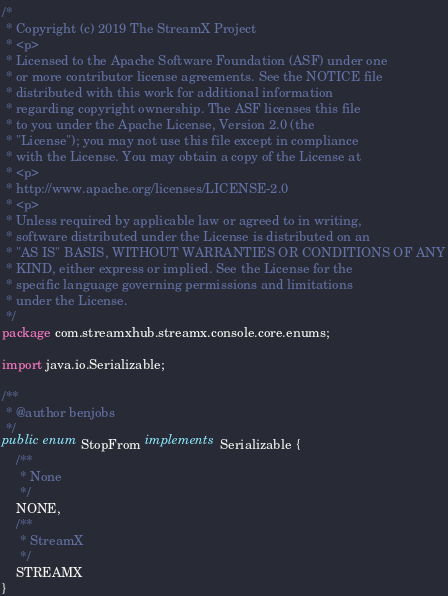Convert code to text. <code><loc_0><loc_0><loc_500><loc_500><_Java_>/*
 * Copyright (c) 2019 The StreamX Project
 * <p>
 * Licensed to the Apache Software Foundation (ASF) under one
 * or more contributor license agreements. See the NOTICE file
 * distributed with this work for additional information
 * regarding copyright ownership. The ASF licenses this file
 * to you under the Apache License, Version 2.0 (the
 * "License"); you may not use this file except in compliance
 * with the License. You may obtain a copy of the License at
 * <p>
 * http://www.apache.org/licenses/LICENSE-2.0
 * <p>
 * Unless required by applicable law or agreed to in writing,
 * software distributed under the License is distributed on an
 * "AS IS" BASIS, WITHOUT WARRANTIES OR CONDITIONS OF ANY
 * KIND, either express or implied. See the License for the
 * specific language governing permissions and limitations
 * under the License.
 */
package com.streamxhub.streamx.console.core.enums;

import java.io.Serializable;

/**
 * @author benjobs
 */
public enum StopFrom implements Serializable {
    /**
     * None
     */
    NONE,
    /**
     * StreamX
     */
    STREAMX
}
</code> 